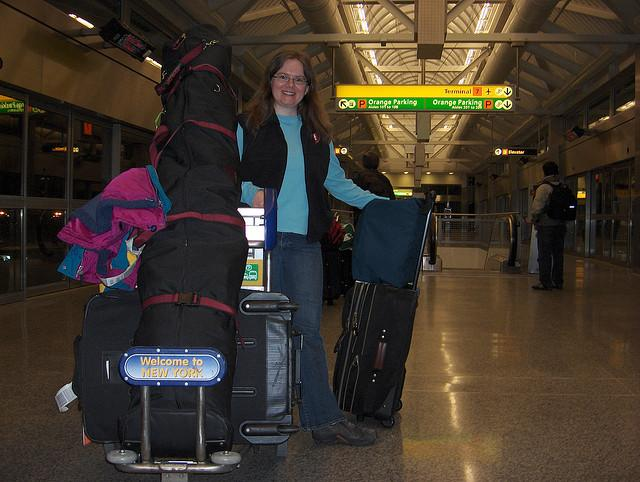What is the woman likely to use to get back home? Please explain your reasoning. airplane. The woman flies. 